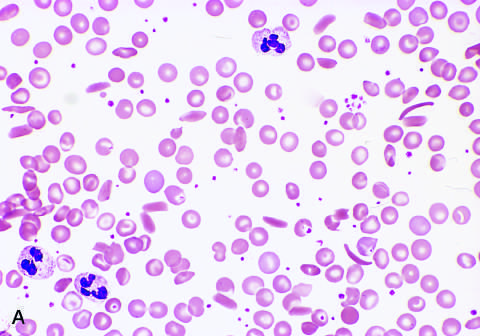what does low magnification show?
Answer the question using a single word or phrase. Sickle cells 